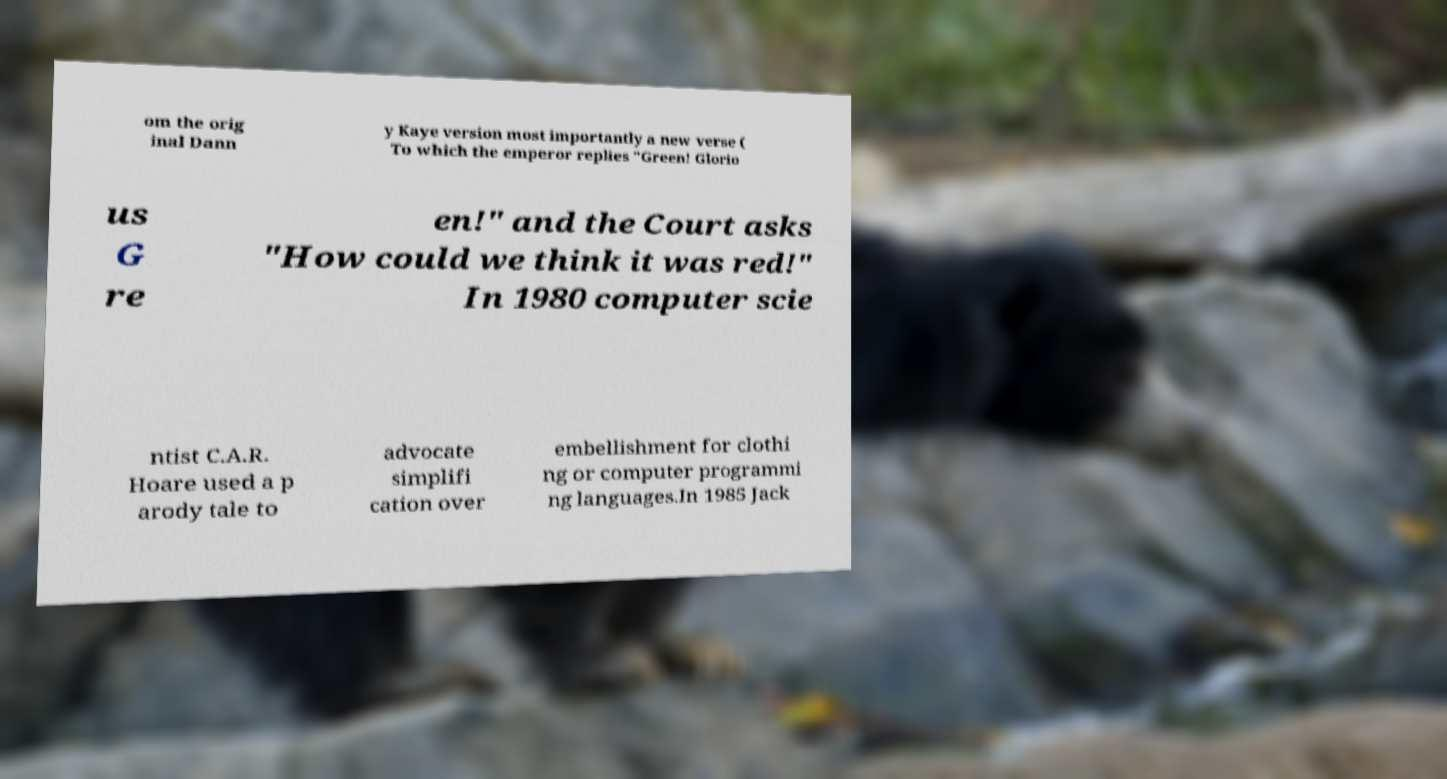Can you accurately transcribe the text from the provided image for me? om the orig inal Dann y Kaye version most importantly a new verse ( To which the emperor replies "Green! Glorio us G re en!" and the Court asks "How could we think it was red!" In 1980 computer scie ntist C.A.R. Hoare used a p arody tale to advocate simplifi cation over embellishment for clothi ng or computer programmi ng languages.In 1985 Jack 